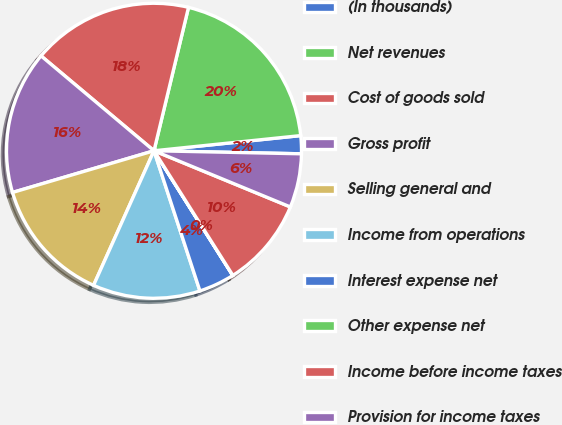<chart> <loc_0><loc_0><loc_500><loc_500><pie_chart><fcel>(In thousands)<fcel>Net revenues<fcel>Cost of goods sold<fcel>Gross profit<fcel>Selling general and<fcel>Income from operations<fcel>Interest expense net<fcel>Other expense net<fcel>Income before income taxes<fcel>Provision for income taxes<nl><fcel>1.97%<fcel>19.6%<fcel>17.64%<fcel>15.68%<fcel>13.72%<fcel>11.76%<fcel>3.93%<fcel>0.01%<fcel>9.8%<fcel>5.89%<nl></chart> 